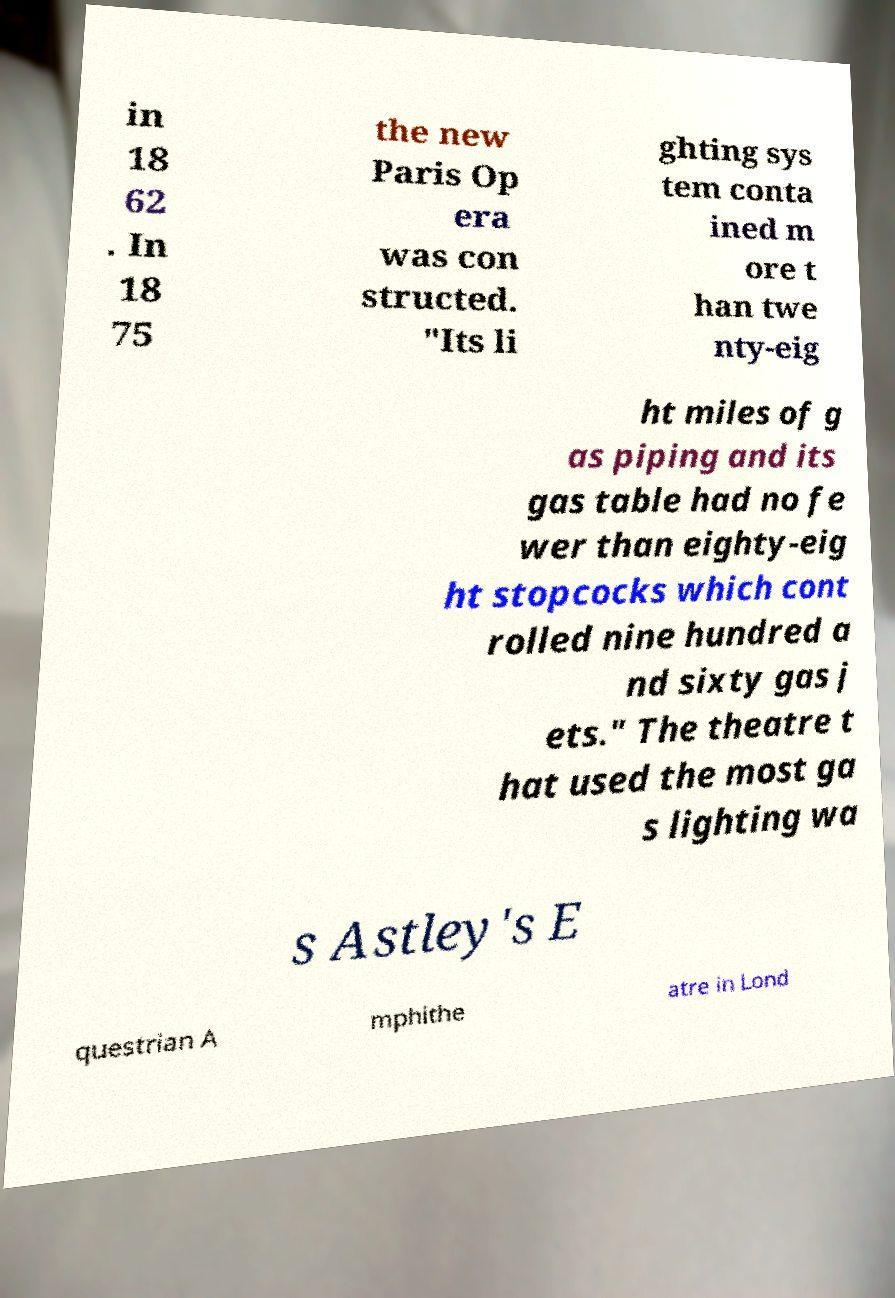Could you extract and type out the text from this image? in 18 62 . In 18 75 the new Paris Op era was con structed. "Its li ghting sys tem conta ined m ore t han twe nty-eig ht miles of g as piping and its gas table had no fe wer than eighty-eig ht stopcocks which cont rolled nine hundred a nd sixty gas j ets." The theatre t hat used the most ga s lighting wa s Astley's E questrian A mphithe atre in Lond 